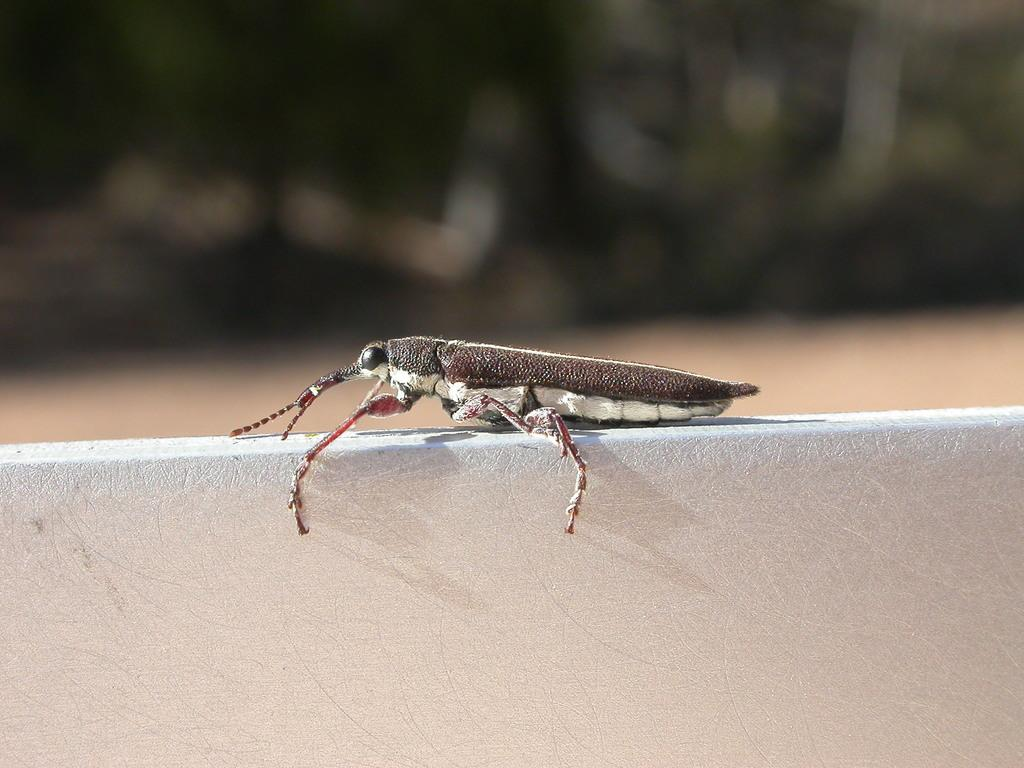What is present in the image? There is an insect in the image. What is the insect located on? The insect is on an object. Can you describe the background of the image? The background of the image is blurry. What type of quilt is visible in the image? There is no quilt present in the image; it only features an insect on an object with a blurry background. 